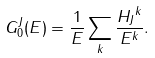<formula> <loc_0><loc_0><loc_500><loc_500>G _ { 0 } ^ { J } ( E ) = \frac { 1 } { E } \sum _ { k } \frac { { H _ { J } } ^ { k } } { E ^ { k } } .</formula> 